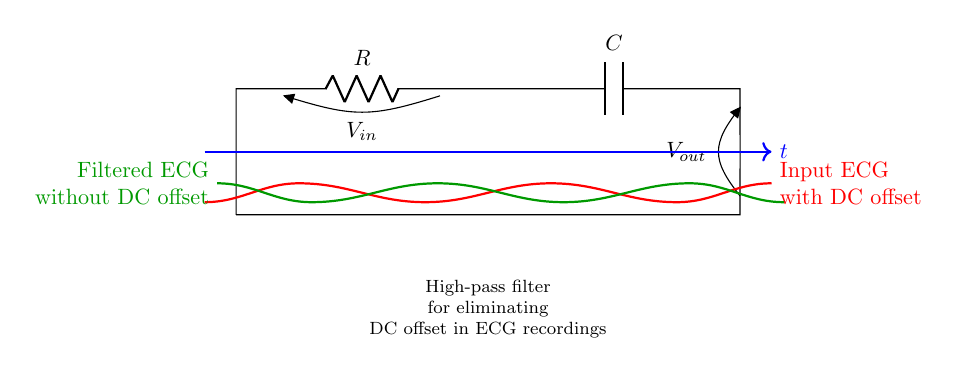What are the two main components in this high-pass filter? The circuit consists of a resistor and a capacitor, which are the primary components used in a high-pass filter configuration.
Answer: Resistor and capacitor What is the function of the high-pass filter in this circuit? The high-pass filter is designed to eliminate the DC offset from the ECG signal, allowing only the AC components (the actual heart signal) to pass through.
Answer: To eliminate DC offset What is the voltage at the input of the circuit? The input voltage, labeled as V in the circuit diagram, represents the voltage from the ECG signal that includes a DC offset.
Answer: V What does V out represent in this circuit? V out refers to the output voltage, which is the filtered ECG signal without the DC offset, showing only the relevant heartbeats.
Answer: Filtered ECG How does the capacitor affect the signal in this high-pass filter? The capacitor blocks DC signals and allows AC signals to pass through, thus removing the DC offset from the input ECG signal.
Answer: Blocks DC What is the expected shape of the output signal after filtering? The output signal should show the heartbeats without the baseline drift caused by the DC offset, appearing as variations around zero voltage.
Answer: Variations around zero voltage What role does the resistor play in determining the filter’s characteristics? The resistor works together with the capacitor to set the cutoff frequency of the high-pass filter, defining which frequencies are allowed to pass.
Answer: Sets cutoff frequency 